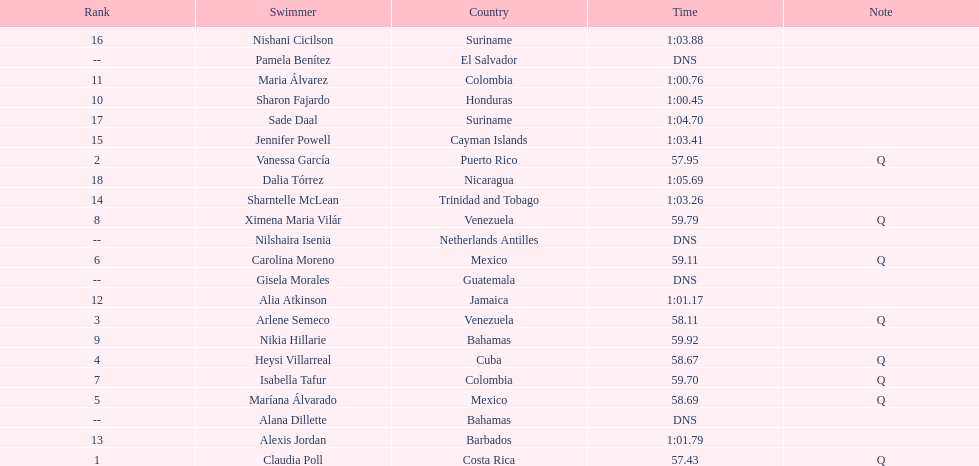How many swimmers had a time of at least 1:00 9. 